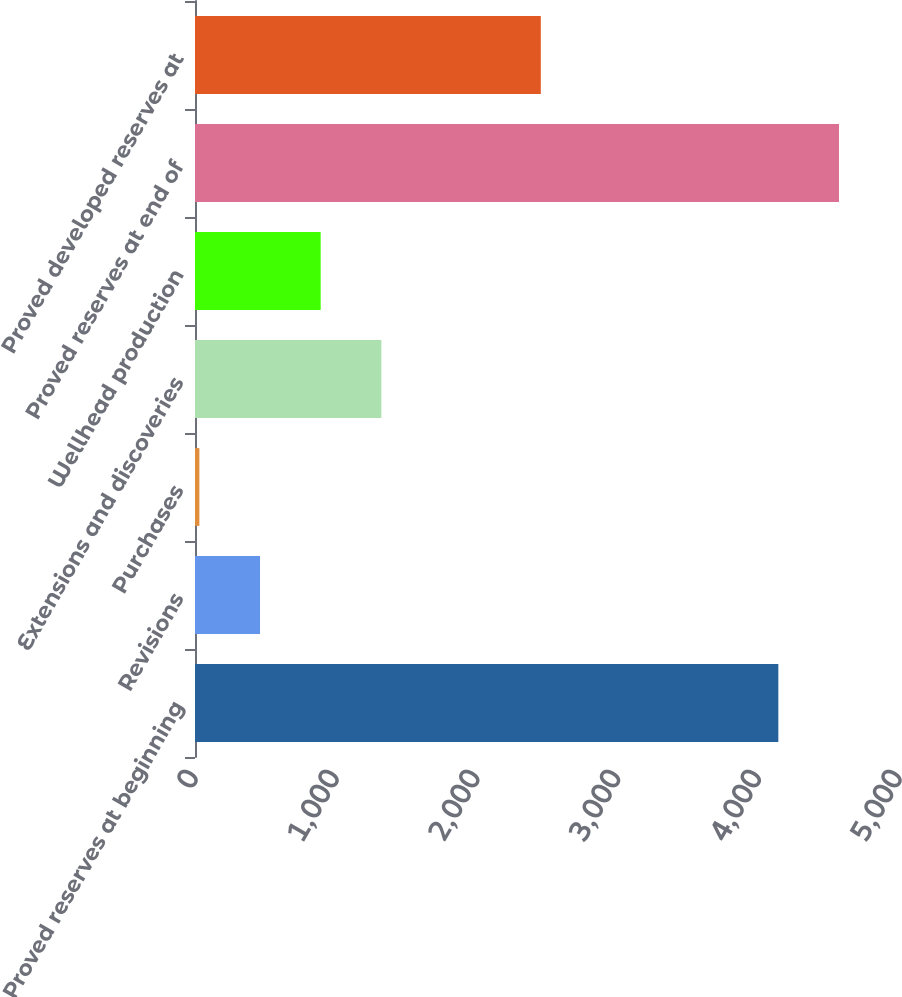Convert chart. <chart><loc_0><loc_0><loc_500><loc_500><bar_chart><fcel>Proved reserves at beginning<fcel>Revisions<fcel>Purchases<fcel>Extensions and discoveries<fcel>Wellhead production<fcel>Proved reserves at end of<fcel>Proved developed reserves at<nl><fcel>4143<fcel>461.8<fcel>31<fcel>1323.4<fcel>892.6<fcel>4573.8<fcel>2456<nl></chart> 